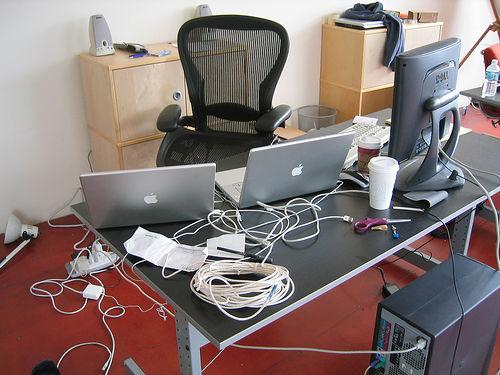Are all of the computer's the same?
Answer briefly. No. How many laptops are there?
Be succinct. 2. How many chairs are there?
Give a very brief answer. 1. 